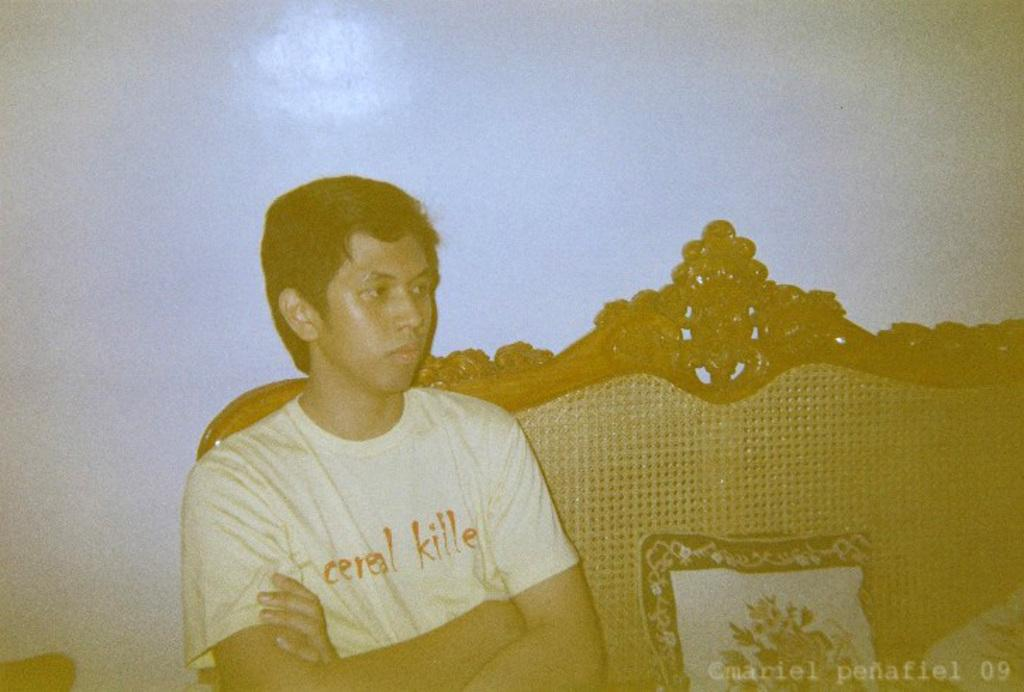Who is present in the image? There is a man in the image. What is the man doing in the image? The man is sitting on a sofa. What is on the sofa with the man? There is a cushion on the sofa. Where is the cushion located in relation to the man? The cushion is on the right side of the person. What time does the alarm go off in the image? There is no alarm present in the image. What type of clock is visible in the image? There is no clock present in the image. 